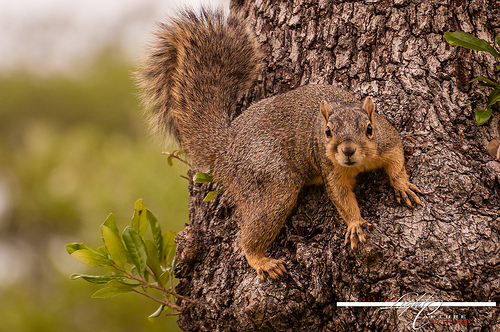<image>
Can you confirm if the squirrel is on the tree? Yes. Looking at the image, I can see the squirrel is positioned on top of the tree, with the tree providing support. Is the squirrel behind the tree? No. The squirrel is not behind the tree. From this viewpoint, the squirrel appears to be positioned elsewhere in the scene. Is the tree under the squirrel? Yes. The tree is positioned underneath the squirrel, with the squirrel above it in the vertical space. Where is the animal in relation to the leaf? Is it to the left of the leaf? No. The animal is not to the left of the leaf. From this viewpoint, they have a different horizontal relationship. 